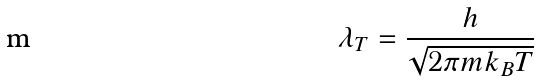Convert formula to latex. <formula><loc_0><loc_0><loc_500><loc_500>\lambda _ { T } = \frac { h } { \sqrt { 2 \pi m k _ { B } T } }</formula> 